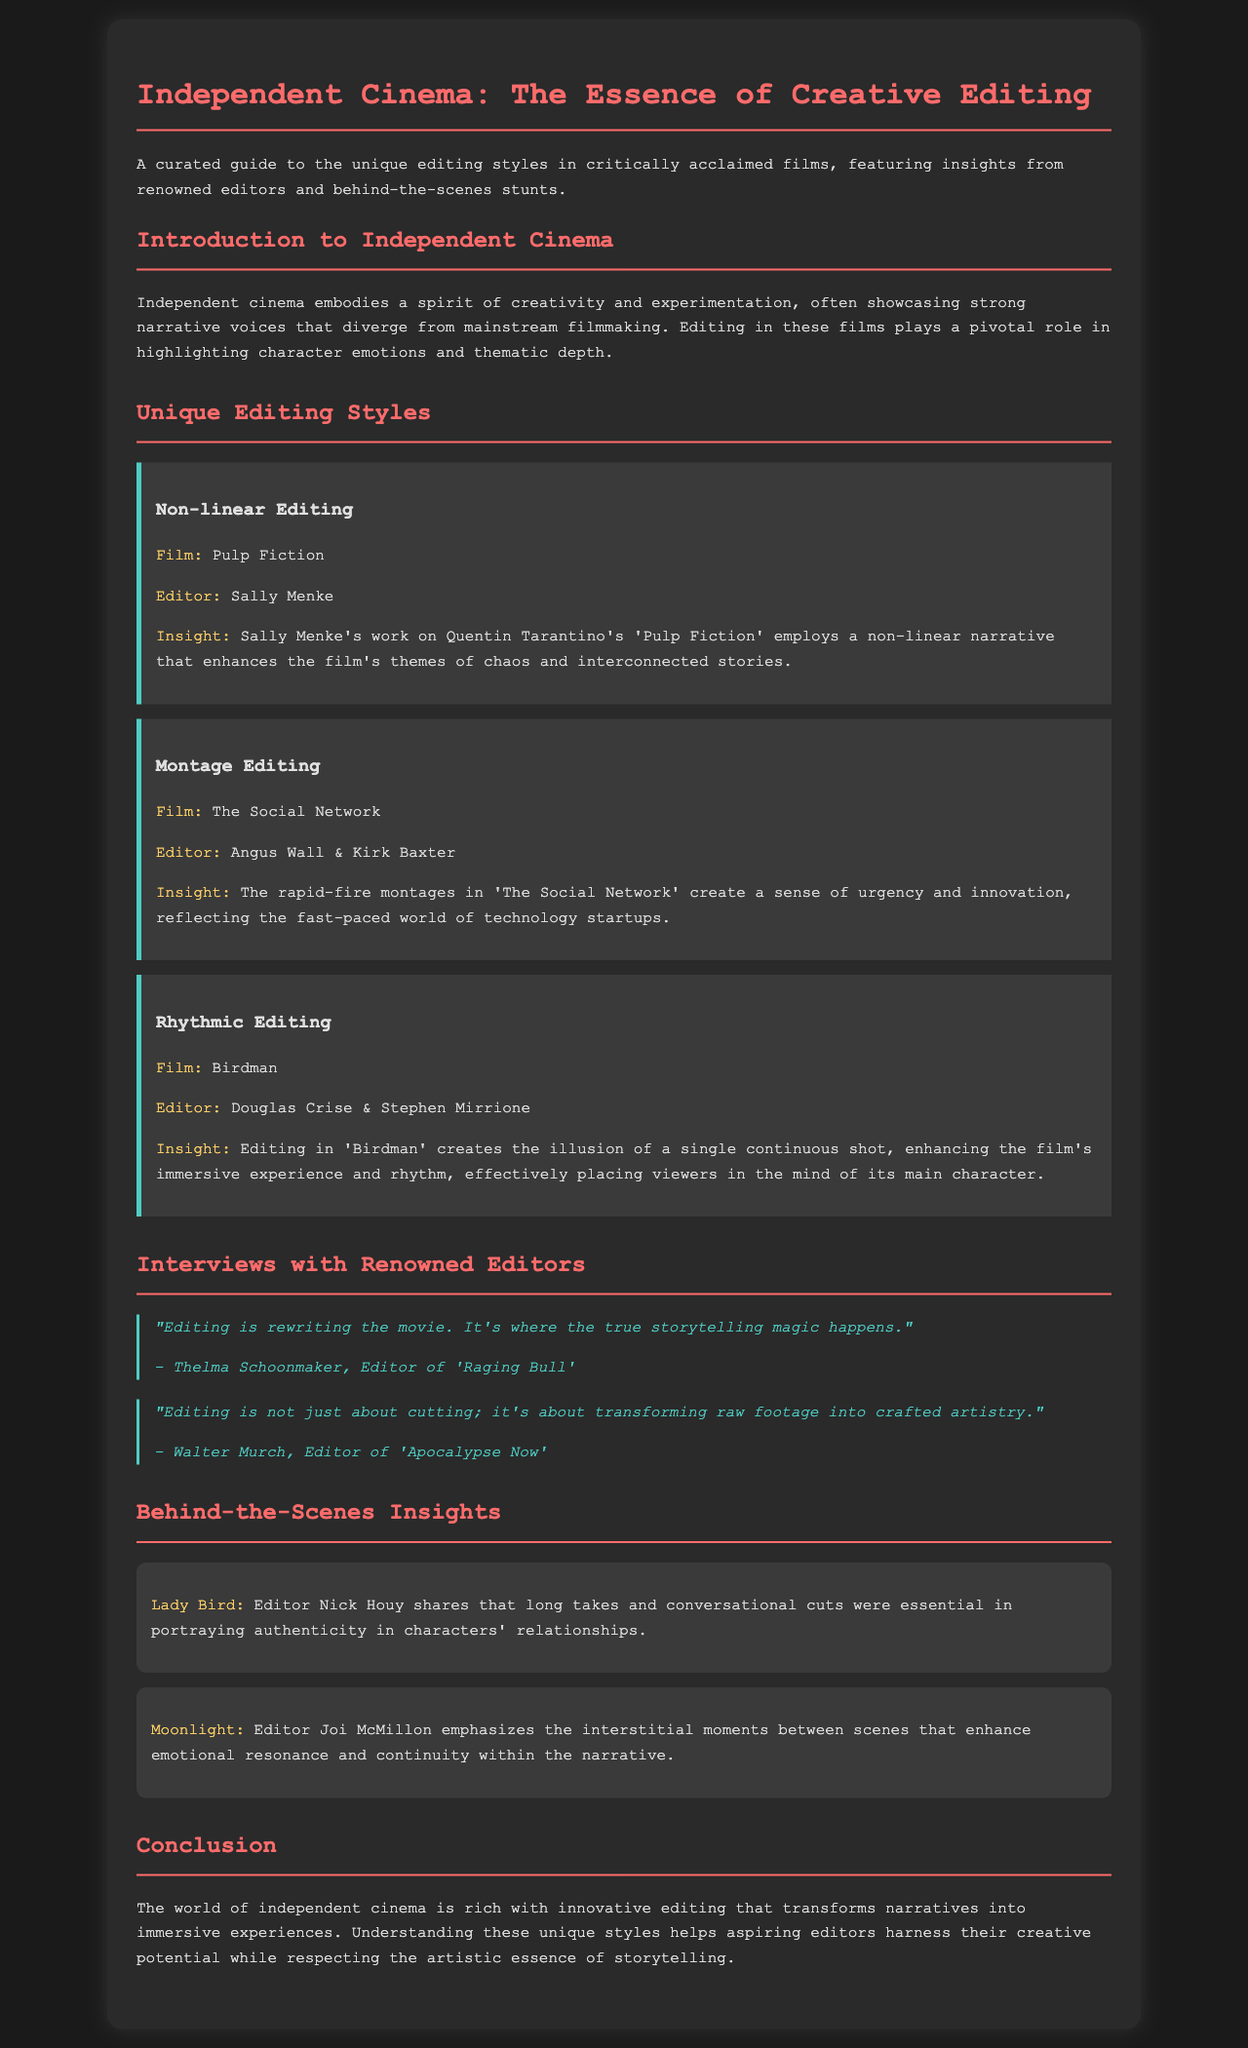What is the title of the brochure? The title of the brochure is indicated prominently at the top of the document.
Answer: Independent Cinema: The Essence of Creative Editing Who is the editor for the film Pulp Fiction? The document states the editor's name next to the film title in the unique editing styles section.
Answer: Sally Menke What editing style is highlighted for the film Lady Bird? The document specifies the editing focus discussed by the editor in the behind-the-scenes insights section.
Answer: Long takes and conversational cuts Which film employs rhythmic editing according to the brochure? The film is mentioned in the unique editing styles section along with its editing description.
Answer: Birdman Who stated, "Editing is rewriting the movie"? The quote is attributed to a prominent editor defined in the interviews section.
Answer: Thelma Schoonmaker What does the editing in Moonlight enhance according to Joi McMillon? The document includes editor insights that explain the effects of editing on the narrative.
Answer: Emotional resonance How many unique editing styles are presented in the brochure? The editing styles listed in the document can be counted to get the total number.
Answer: Three What is a key characteristic of independent cinema mentioned in the brochure? The introduction section outlines the defining traits of independent cinema.
Answer: Creativity and experimentation 